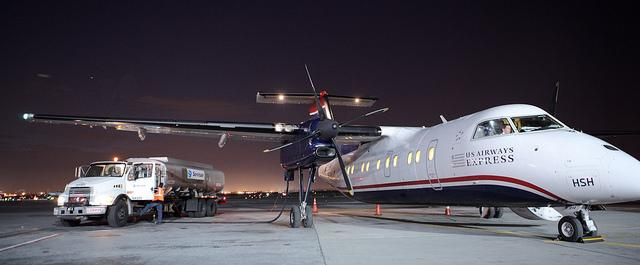What color is the underbelly of this private jet?

Choices:
A) green
B) blue
C) orange
D) black black 